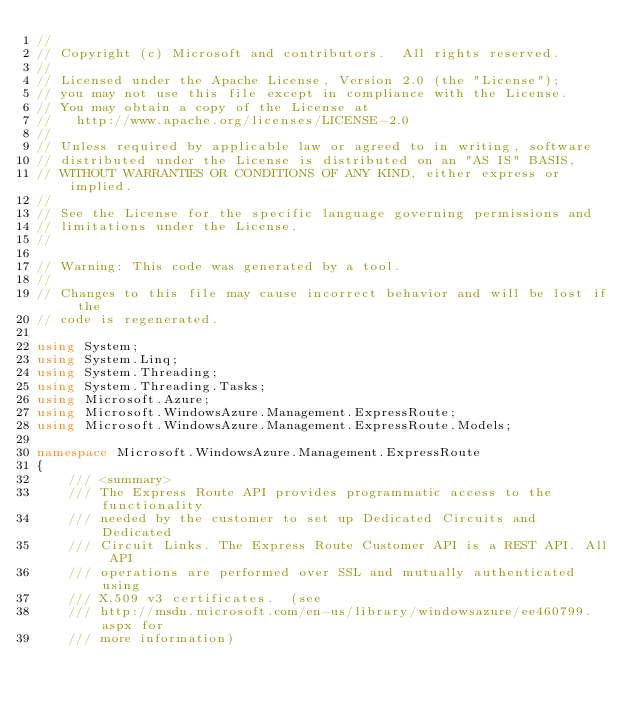Convert code to text. <code><loc_0><loc_0><loc_500><loc_500><_C#_>// 
// Copyright (c) Microsoft and contributors.  All rights reserved.
// 
// Licensed under the Apache License, Version 2.0 (the "License");
// you may not use this file except in compliance with the License.
// You may obtain a copy of the License at
//   http://www.apache.org/licenses/LICENSE-2.0
// 
// Unless required by applicable law or agreed to in writing, software
// distributed under the License is distributed on an "AS IS" BASIS,
// WITHOUT WARRANTIES OR CONDITIONS OF ANY KIND, either express or implied.
// 
// See the License for the specific language governing permissions and
// limitations under the License.
// 

// Warning: This code was generated by a tool.
// 
// Changes to this file may cause incorrect behavior and will be lost if the
// code is regenerated.

using System;
using System.Linq;
using System.Threading;
using System.Threading.Tasks;
using Microsoft.Azure;
using Microsoft.WindowsAzure.Management.ExpressRoute;
using Microsoft.WindowsAzure.Management.ExpressRoute.Models;

namespace Microsoft.WindowsAzure.Management.ExpressRoute
{
    /// <summary>
    /// The Express Route API provides programmatic access to the functionality
    /// needed by the customer to set up Dedicated Circuits and Dedicated
    /// Circuit Links. The Express Route Customer API is a REST API. All API
    /// operations are performed over SSL and mutually authenticated using
    /// X.509 v3 certificates.  (see
    /// http://msdn.microsoft.com/en-us/library/windowsazure/ee460799.aspx for
    /// more information)</code> 